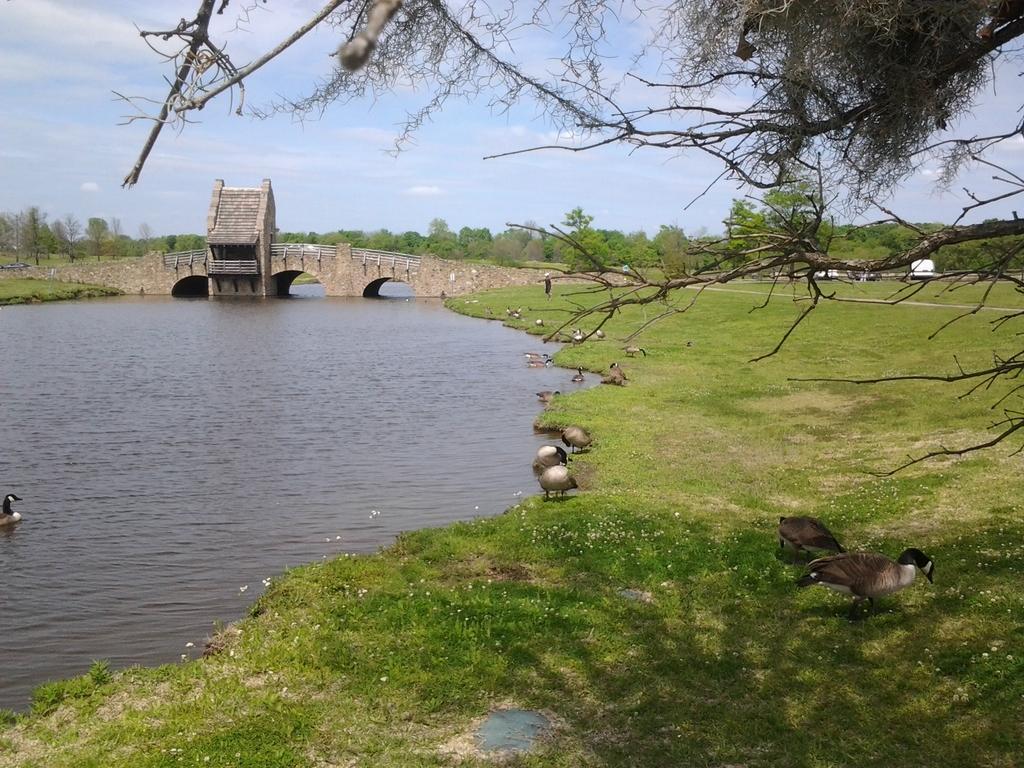Please provide a concise description of this image. In this image we can see the bridge, water, grass and also the birds. We can also see the trees and also the sky with some clouds. 